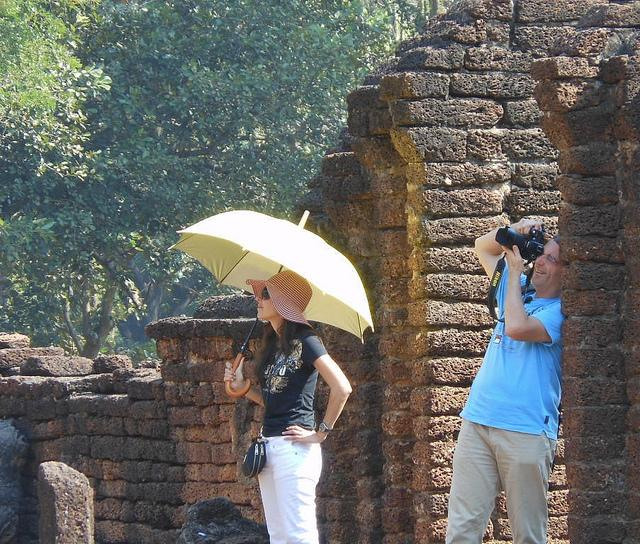What is he observing through the lens? trees 